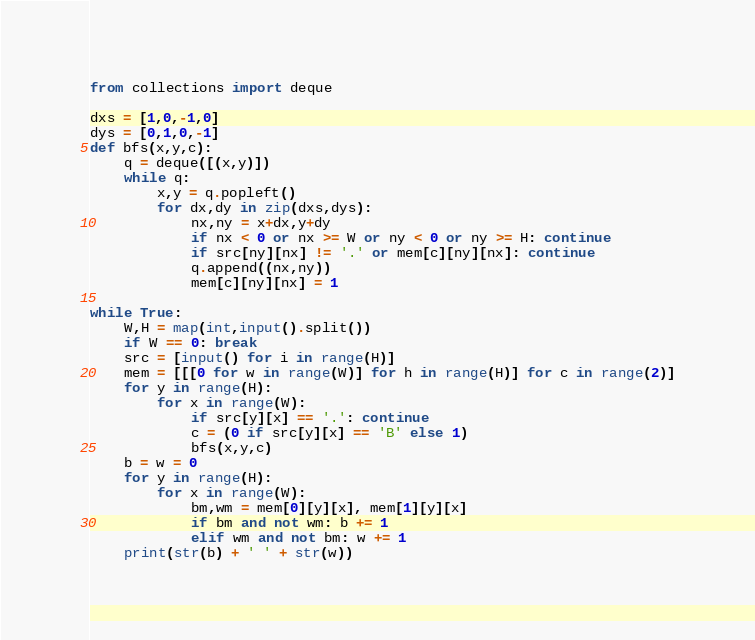Convert code to text. <code><loc_0><loc_0><loc_500><loc_500><_Python_>from collections import deque

dxs = [1,0,-1,0]
dys = [0,1,0,-1]
def bfs(x,y,c):
    q = deque([(x,y)])
    while q:
        x,y = q.popleft()
        for dx,dy in zip(dxs,dys):
            nx,ny = x+dx,y+dy
            if nx < 0 or nx >= W or ny < 0 or ny >= H: continue
            if src[ny][nx] != '.' or mem[c][ny][nx]: continue
            q.append((nx,ny))
            mem[c][ny][nx] = 1

while True:
    W,H = map(int,input().split())
    if W == 0: break
    src = [input() for i in range(H)]
    mem = [[[0 for w in range(W)] for h in range(H)] for c in range(2)]
    for y in range(H):
        for x in range(W):
            if src[y][x] == '.': continue
            c = (0 if src[y][x] == 'B' else 1)
            bfs(x,y,c)
    b = w = 0
    for y in range(H):
        for x in range(W):
            bm,wm = mem[0][y][x], mem[1][y][x]
            if bm and not wm: b += 1
            elif wm and not bm: w += 1
    print(str(b) + ' ' + str(w))</code> 